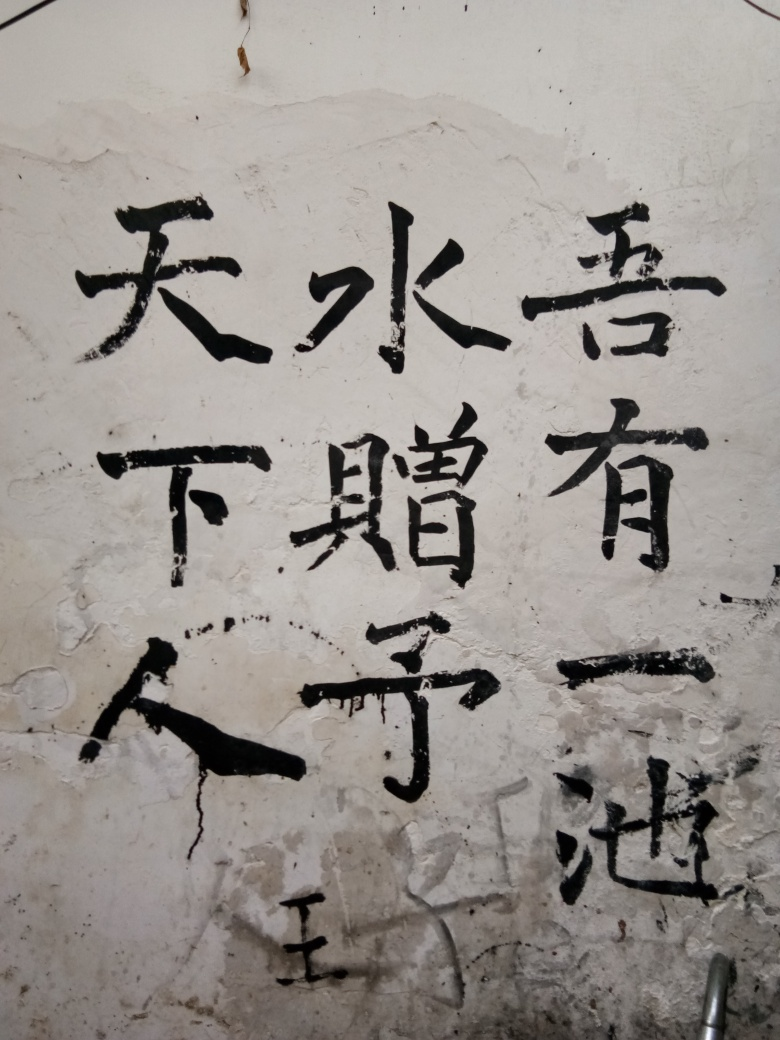Describe the condition of the wall and its impact on the overall aesthetic. The wall's texture is rough, with peeling layers and visible cracks, which add a rustic and authentic charm to the image. It evokes a sense of history and perhaps even neglect, contrasting the permanence of the written characters with the transitory nature of their physical background. 